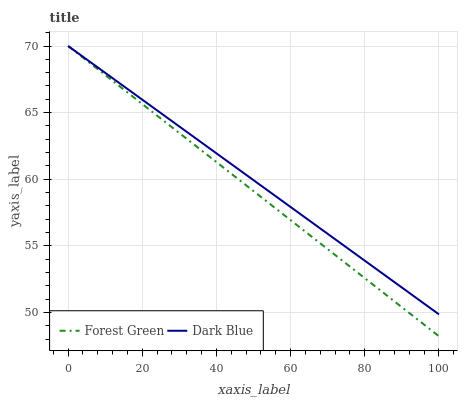Does Forest Green have the minimum area under the curve?
Answer yes or no. Yes. Does Dark Blue have the maximum area under the curve?
Answer yes or no. Yes. Does Forest Green have the maximum area under the curve?
Answer yes or no. No. Is Forest Green the smoothest?
Answer yes or no. Yes. Is Dark Blue the roughest?
Answer yes or no. Yes. Is Forest Green the roughest?
Answer yes or no. No. Does Forest Green have the lowest value?
Answer yes or no. Yes. Does Forest Green have the highest value?
Answer yes or no. Yes. Does Dark Blue intersect Forest Green?
Answer yes or no. Yes. Is Dark Blue less than Forest Green?
Answer yes or no. No. Is Dark Blue greater than Forest Green?
Answer yes or no. No. 